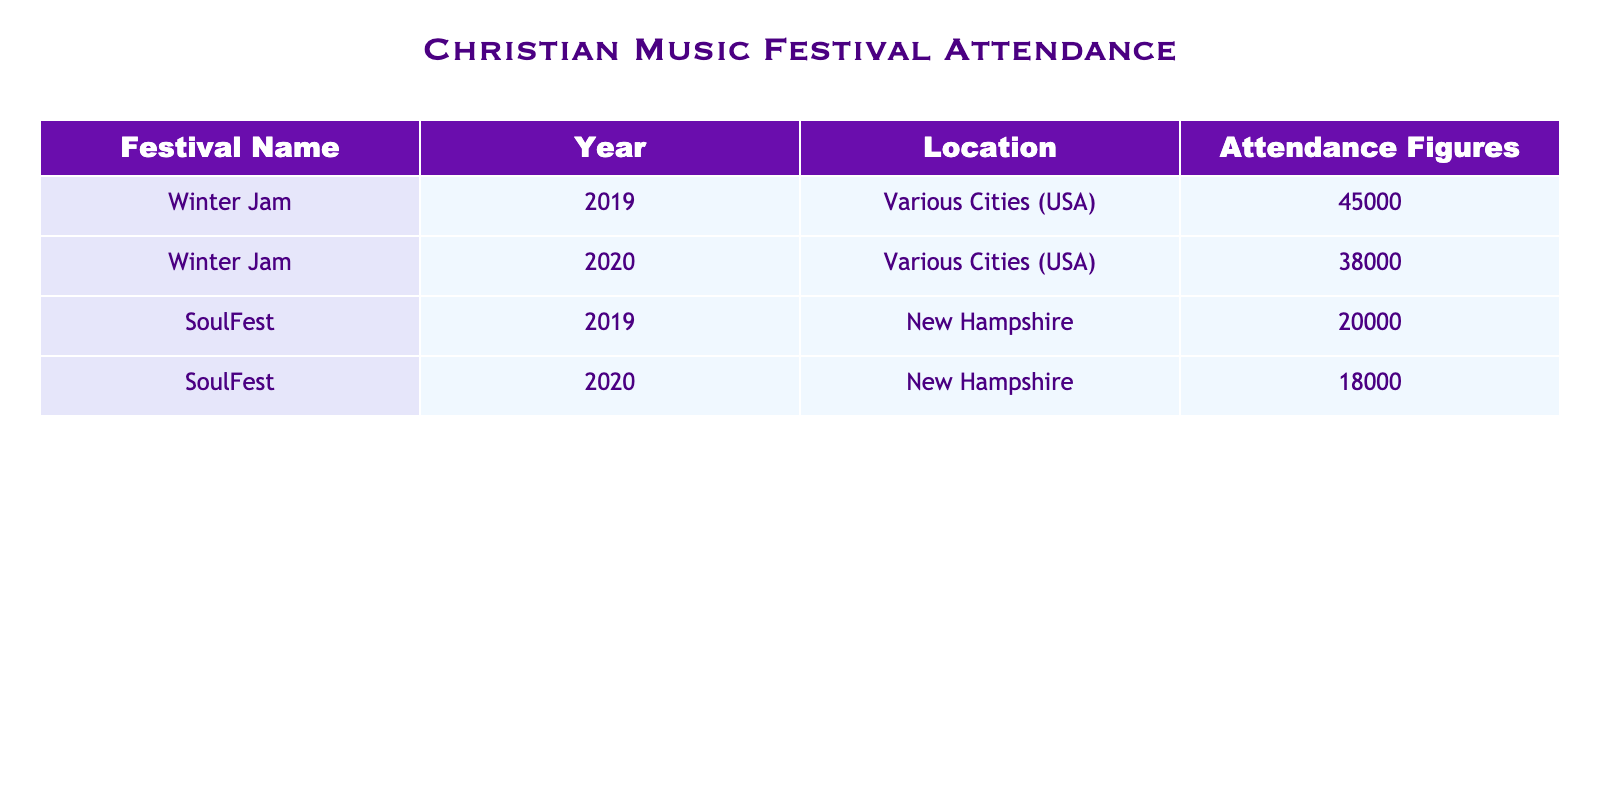What was the attendance figure for Winter Jam in 2019? The table states that the attendance figure for Winter Jam in 2019 is 45000.
Answer: 45000 What year did SoulFest have the highest attendance? By comparing the years listed for SoulFest, 2019 had an attendance of 20000, while 2020 had 18000. Therefore, 2019 had the highest attendance.
Answer: 2019 What is the total attendance for Winter Jam across 2019 and 2020? The attendance figures for Winter Jam are 45000 in 2019 and 38000 in 2020. Adding these two figures, 45000 + 38000 = 83000 gives the total attendance for this period.
Answer: 83000 Did the attendance for SoulFest decrease from 2019 to 2020? The attendance figures for SoulFest are 20000 in 2019 and 18000 in 2020. Since 18000 is less than 20000, it confirms that the attendance did indeed decrease.
Answer: Yes What is the average attendance for all festivals listed in the table? The attendance figures are 45000, 38000, 20000, and 18000. Summing these gives 45000 + 38000 + 20000 + 18000 = 121000. There are 4 attendance figures, so the average is 121000 divided by 4, which equals 30250.
Answer: 30250 Which festival had the lowest attendance in 2020? Comparing the 2020 attendance figures, Winter Jam had 38000 and SoulFest had 18000. Since 18000 is less than 38000, SoulFest had the lowest attendance in 2020.
Answer: SoulFest In which year did Winter Jam normally have an attendance above 40000? The table shows Winter Jam's attendance was 45000 in 2019 and dropped to 38000 in 2020. Thus, 2019 is the only year with attendance above 40000.
Answer: 2019 What is the difference in attendance between Winter Jam 2020 and SoulFest 2020? Winter Jam had an attendance of 38000 in 2020, while SoulFest's attendance was 18000. The difference is calculated by 38000 - 18000 = 20000.
Answer: 20000 How many festivals had an attendance figure exceeding 30000 in the table? Looking at the attendance figures, only Winter Jam's attendance in 2019 (45000) and Winter Jam's attendance in 2020 (38000) exceed 30000. Thus, there are 2 festivals that had attendance above 30000.
Answer: 2 